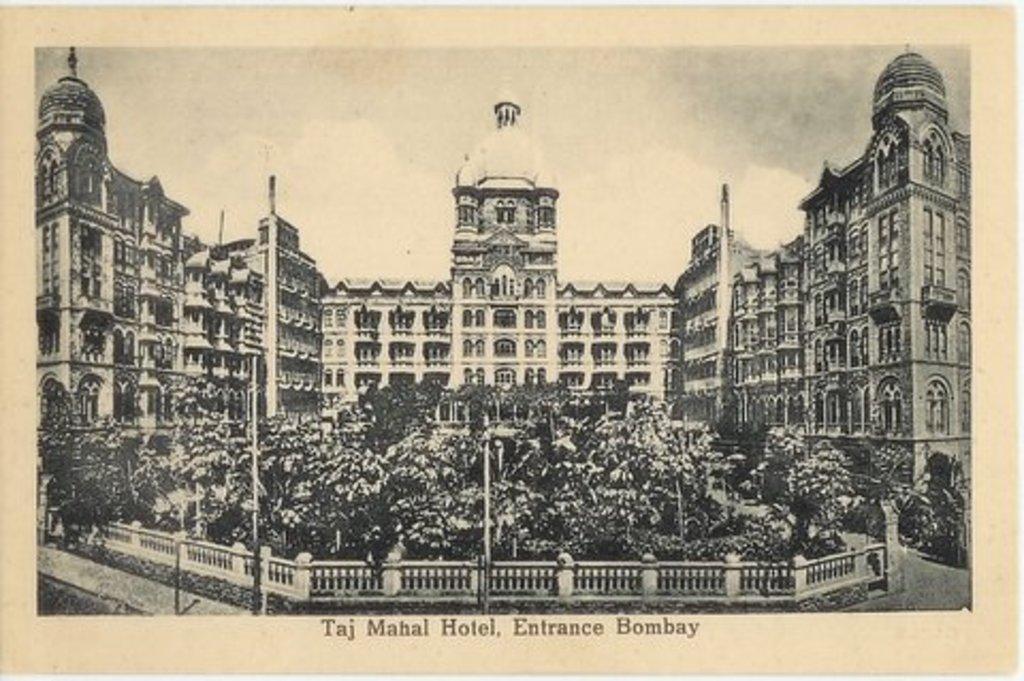What hotel is shown on the picture?
Provide a short and direct response. Taj mahal hotel. 